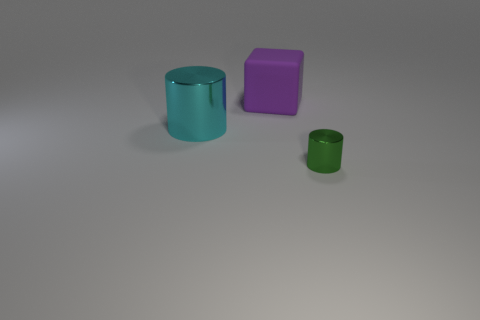Add 3 tiny yellow metal cylinders. How many objects exist? 6 Subtract all cylinders. How many objects are left? 1 Add 1 tiny gray rubber things. How many tiny gray rubber things exist? 1 Subtract 1 green cylinders. How many objects are left? 2 Subtract all small red rubber cylinders. Subtract all green shiny things. How many objects are left? 2 Add 2 large cylinders. How many large cylinders are left? 3 